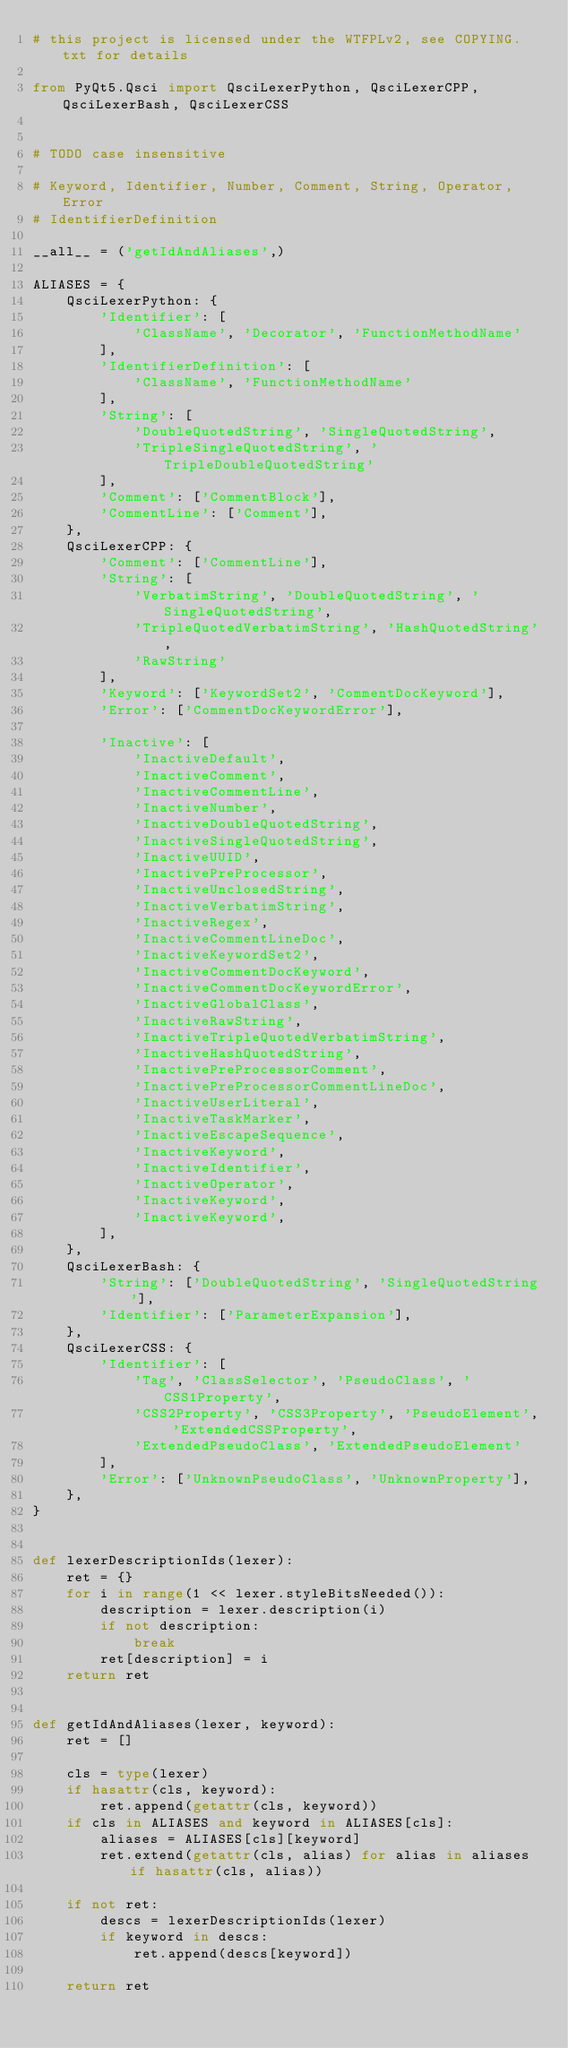Convert code to text. <code><loc_0><loc_0><loc_500><loc_500><_Python_># this project is licensed under the WTFPLv2, see COPYING.txt for details

from PyQt5.Qsci import QsciLexerPython, QsciLexerCPP, QsciLexerBash, QsciLexerCSS


# TODO case insensitive

# Keyword, Identifier, Number, Comment, String, Operator, Error
# IdentifierDefinition

__all__ = ('getIdAndAliases',)

ALIASES = {
	QsciLexerPython: {
		'Identifier': [
			'ClassName', 'Decorator', 'FunctionMethodName'
		],
		'IdentifierDefinition': [
			'ClassName', 'FunctionMethodName'
		],
		'String': [
			'DoubleQuotedString', 'SingleQuotedString',
			'TripleSingleQuotedString', 'TripleDoubleQuotedString'
		],
		'Comment': ['CommentBlock'],
		'CommentLine': ['Comment'],
	},
	QsciLexerCPP: {
		'Comment': ['CommentLine'],
		'String': [
			'VerbatimString', 'DoubleQuotedString', 'SingleQuotedString',
			'TripleQuotedVerbatimString', 'HashQuotedString',
			'RawString'
		],
		'Keyword': ['KeywordSet2', 'CommentDocKeyword'],
		'Error': ['CommentDocKeywordError'],

		'Inactive': [
			'InactiveDefault',
			'InactiveComment',
			'InactiveCommentLine',
			'InactiveNumber',
			'InactiveDoubleQuotedString',
			'InactiveSingleQuotedString',
			'InactiveUUID',
			'InactivePreProcessor',
			'InactiveUnclosedString',
			'InactiveVerbatimString',
			'InactiveRegex',
			'InactiveCommentLineDoc',
			'InactiveKeywordSet2',
			'InactiveCommentDocKeyword',
			'InactiveCommentDocKeywordError',
			'InactiveGlobalClass',
			'InactiveRawString',
			'InactiveTripleQuotedVerbatimString',
			'InactiveHashQuotedString',
			'InactivePreProcessorComment',
			'InactivePreProcessorCommentLineDoc',
			'InactiveUserLiteral',
			'InactiveTaskMarker',
			'InactiveEscapeSequence',
			'InactiveKeyword',
			'InactiveIdentifier',
			'InactiveOperator',
			'InactiveKeyword',
			'InactiveKeyword',
		],
	},
	QsciLexerBash: {
		'String': ['DoubleQuotedString', 'SingleQuotedString'],
		'Identifier': ['ParameterExpansion'],
	},
	QsciLexerCSS: {
		'Identifier': [
			'Tag', 'ClassSelector', 'PseudoClass', 'CSS1Property',
			'CSS2Property', 'CSS3Property', 'PseudoElement', 'ExtendedCSSProperty',
			'ExtendedPseudoClass', 'ExtendedPseudoElement'
		],
		'Error': ['UnknownPseudoClass', 'UnknownProperty'],
	},
}


def lexerDescriptionIds(lexer):
	ret = {}
	for i in range(1 << lexer.styleBitsNeeded()):
		description = lexer.description(i)
		if not description:
			break
		ret[description] = i
	return ret


def getIdAndAliases(lexer, keyword):
	ret = []

	cls = type(lexer)
	if hasattr(cls, keyword):
		ret.append(getattr(cls, keyword))
	if cls in ALIASES and keyword in ALIASES[cls]:
		aliases = ALIASES[cls][keyword]
		ret.extend(getattr(cls, alias) for alias in aliases if hasattr(cls, alias))

	if not ret:
		descs = lexerDescriptionIds(lexer)
		if keyword in descs:
			ret.append(descs[keyword])

	return ret
</code> 